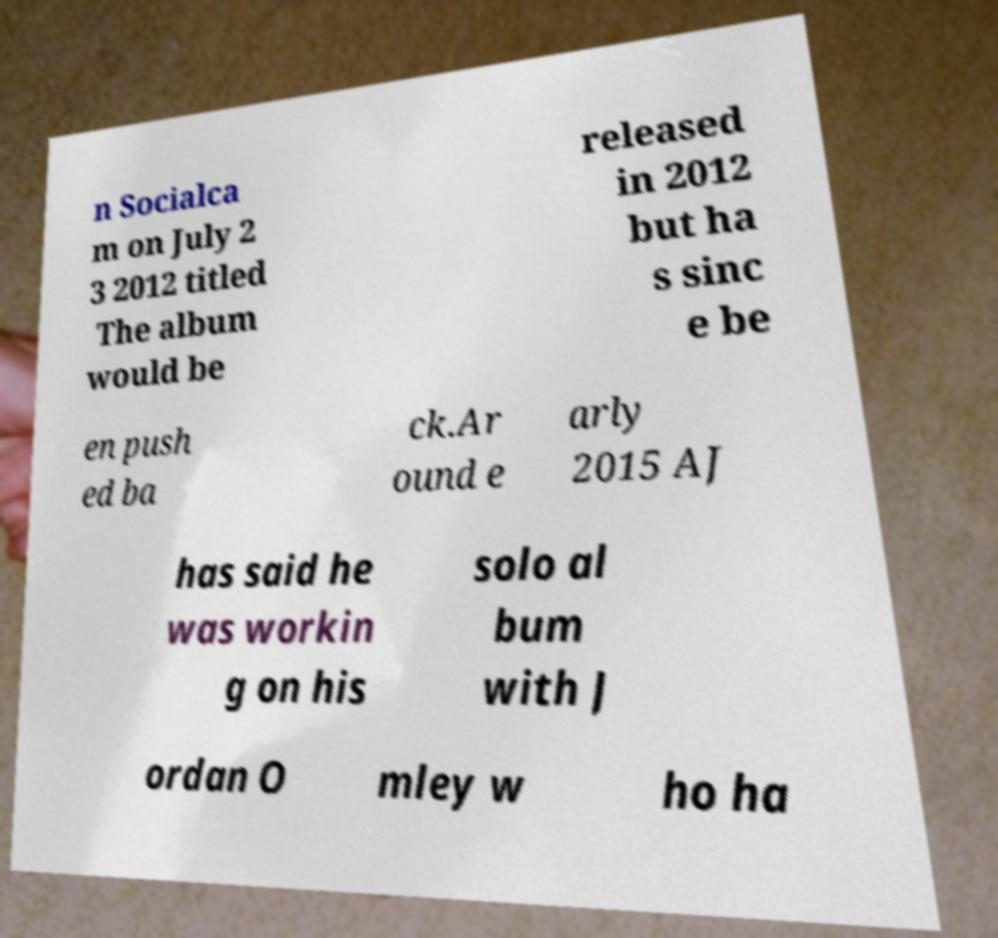Please read and relay the text visible in this image. What does it say? n Socialca m on July 2 3 2012 titled The album would be released in 2012 but ha s sinc e be en push ed ba ck.Ar ound e arly 2015 AJ has said he was workin g on his solo al bum with J ordan O mley w ho ha 